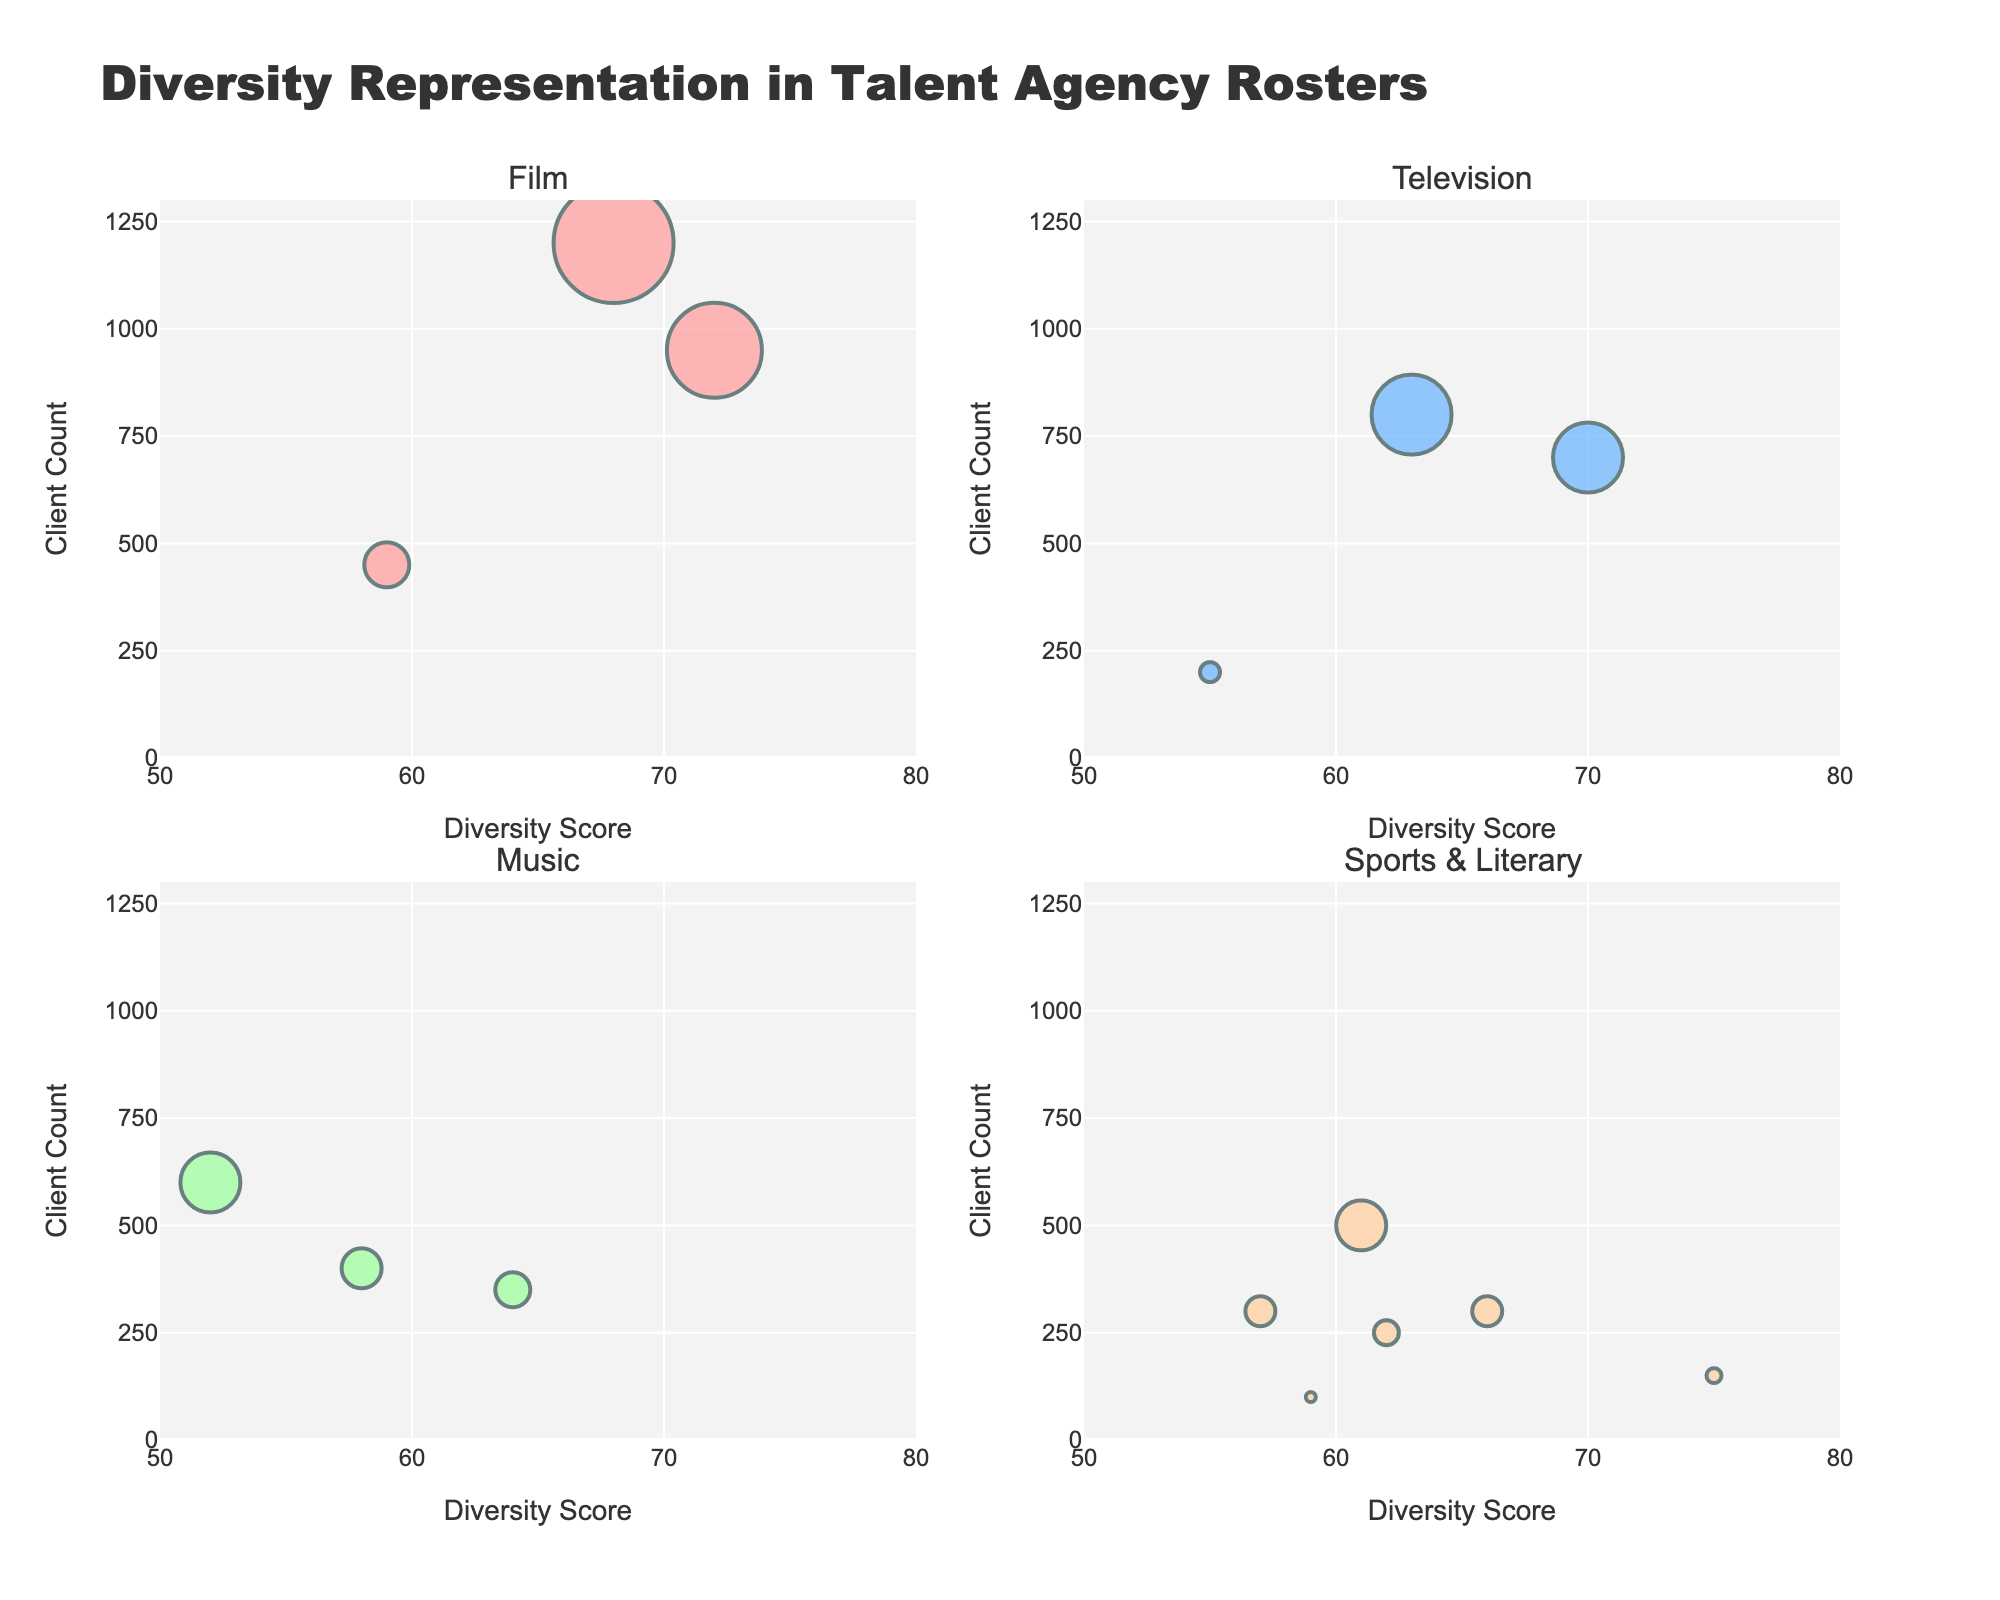How many agencies are represented in the Music sector? There are three data points in the subplot for Music, each representing a different agency. Thus, there are three agencies in the Music sector.
Answer: 3 Which entertainment sector has the highest diversity score among all the agencies? Looking at the plots, Miami's Klutch Sports Group in the Sports sector has the highest diversity score of 75.
Answer: Sports What is the total client count for all agencies in the Film sector? The client counts for the Film sector are 1200 (CAA), 950 (WME), and 450 (United Agents). Sum: 1200 + 950 + 450 = 2600.
Answer: 2600 Which agency has the lowest diversity score in the Television sector, and what is that score? In the Television subplot, the lowest diversity score is 55, which belongs to Oscars Abrams Zimel in Toronto.
Answer: Oscars Abrams Zimel, 55 Compare the average diversity score of agencies in the London region across all sectors to those in New York. Which region has a higher average? London's agencies in Film, Music, and Literary have diversity scores of 59, 58, and 62 respectively. New York's agencies in Film, Television, and Literary have scores of 72, 70, and 66 respectively. Average for London: (59+58+62)/3 = 59.67. Average for New York: (72+70+66)/3 = 69.33. Therefore, New York has a higher average score.
Answer: New York Which entertainment sector has the highest client count for a single agency, and what is that count? The Film sector's CAA agency in Los Angeles has the highest single client count with 1200 clients.
Answer: Film, 1200 Are there any entertainment sectors where all agencies listed have diversity scores below 60? By examining all sectors, only Literary has all agencies listed (New York, London, Paris) with diversity scores below 60.
Answer: No Which sector has the largest bubble size variance, interpreted by the difference between the largest and smallest agency client counts? Film's largest client count is 1200 (CAA) and its smallest is 450 (United Agents). The variance is 1200 - 450 = 750. Music's largest is 600 and smallest is 350, variance 250. Television's largest is 800 and smallest is 200, variance 600. Sports & Literary combined largest is 500 (Wasserman) and smallest is 100 (Susanna Lea Associates), variance 400. So, Film has the largest variance of 750.
Answer: Film Which agency has the highest diversity score in the Literary sector, and what is that score? Among Literary agencies, Curtis Brown in New York has the highest diversity score of 66.
Answer: Curtis Brown, 66 